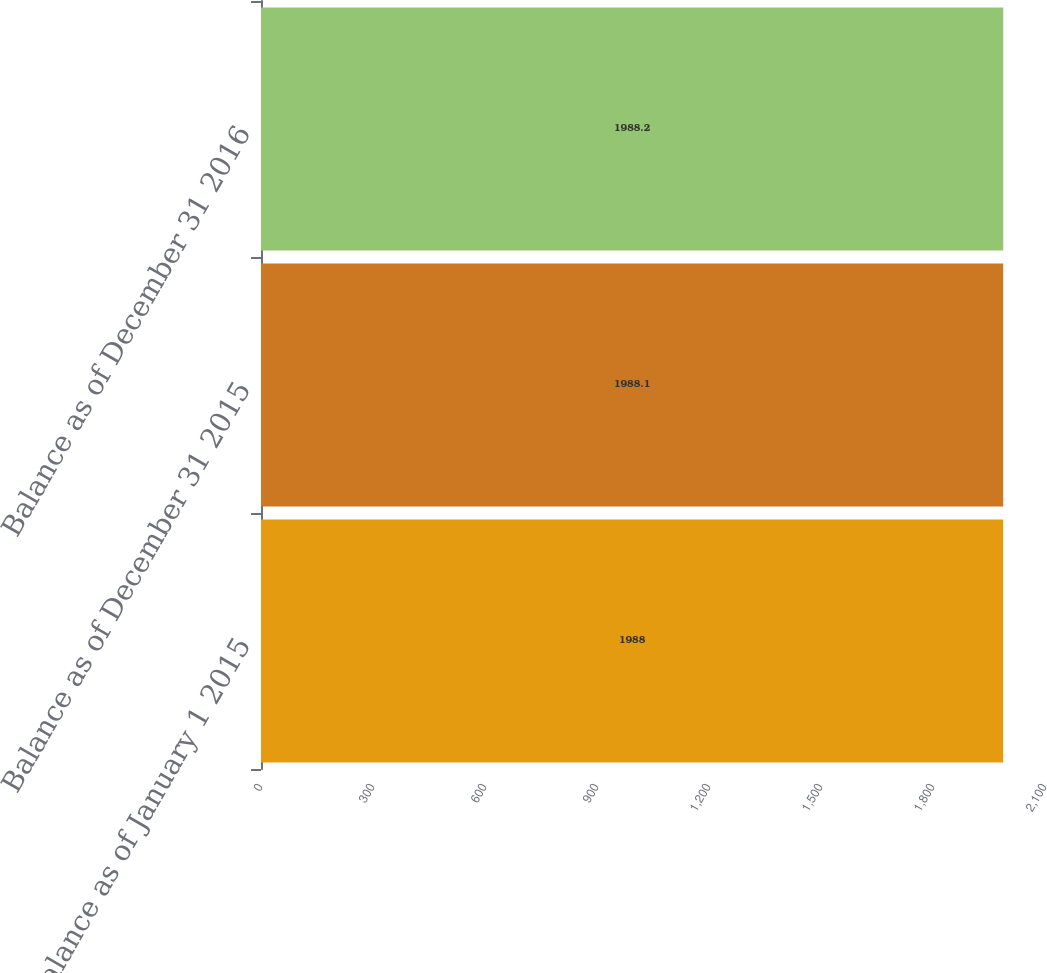<chart> <loc_0><loc_0><loc_500><loc_500><bar_chart><fcel>Balance as of January 1 2015<fcel>Balance as of December 31 2015<fcel>Balance as of December 31 2016<nl><fcel>1988<fcel>1988.1<fcel>1988.2<nl></chart> 